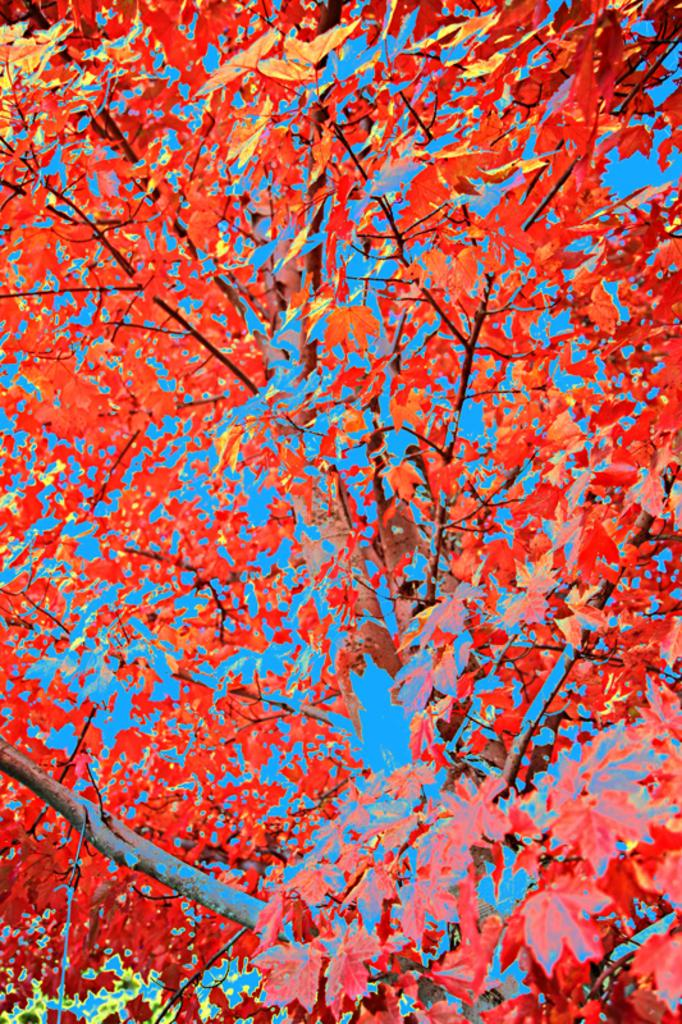What is depicted in the image? There is a painting of a tree in the image. What type of liquid can be seen dripping from the tree in the image? There is no liquid visible in the image; it is a painting of a tree. What color are the lips of the person in the image? There is no person present in the image, only a painting of a tree. 